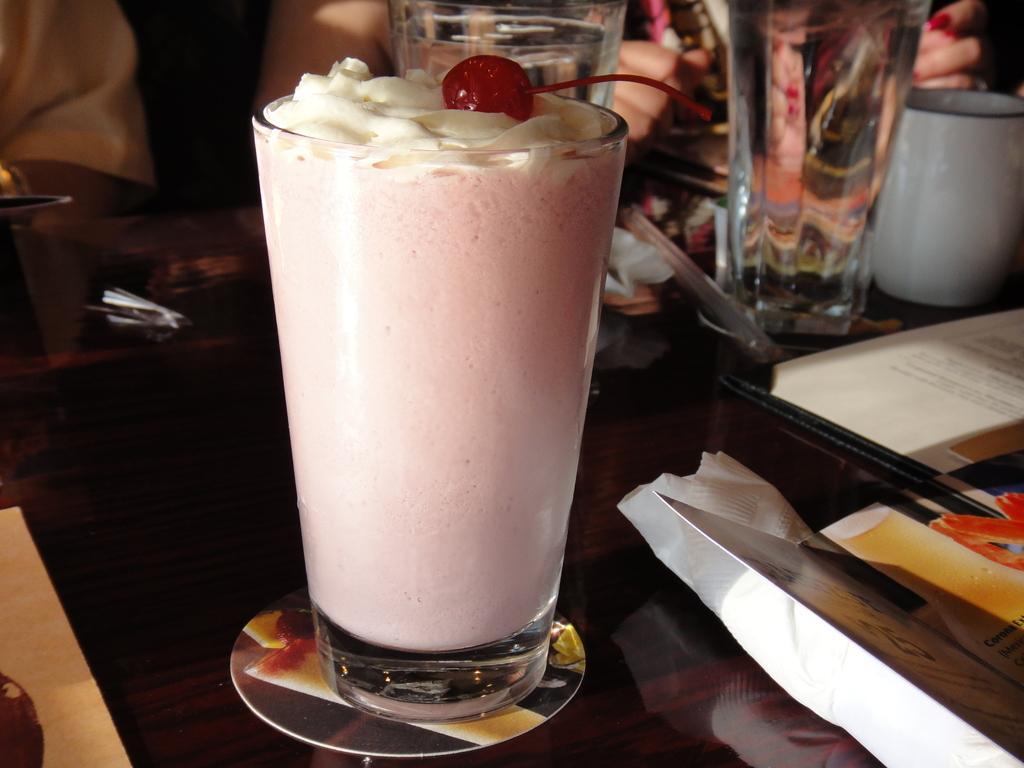How would you summarize this image in a sentence or two? In this picture we can see a table and on the table, there are glasses, a cup, menu card, tissue paper and some objects. In the glass there is liquid and a cherry. Behind the table, there are people. 